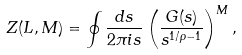<formula> <loc_0><loc_0><loc_500><loc_500>Z ( L , M ) = \oint \frac { d s } { 2 \pi i s } \left ( \frac { G ( s ) } { s ^ { 1 / \rho - 1 } } \right ) ^ { M } ,</formula> 